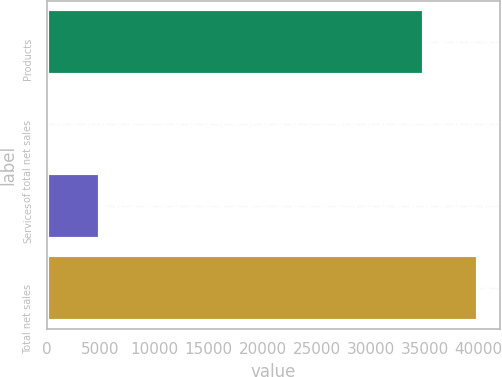<chart> <loc_0><loc_0><loc_500><loc_500><bar_chart><fcel>Products<fcel>of total net sales<fcel>Services<fcel>Total net sales<nl><fcel>34984<fcel>87.6<fcel>4962<fcel>39946<nl></chart> 